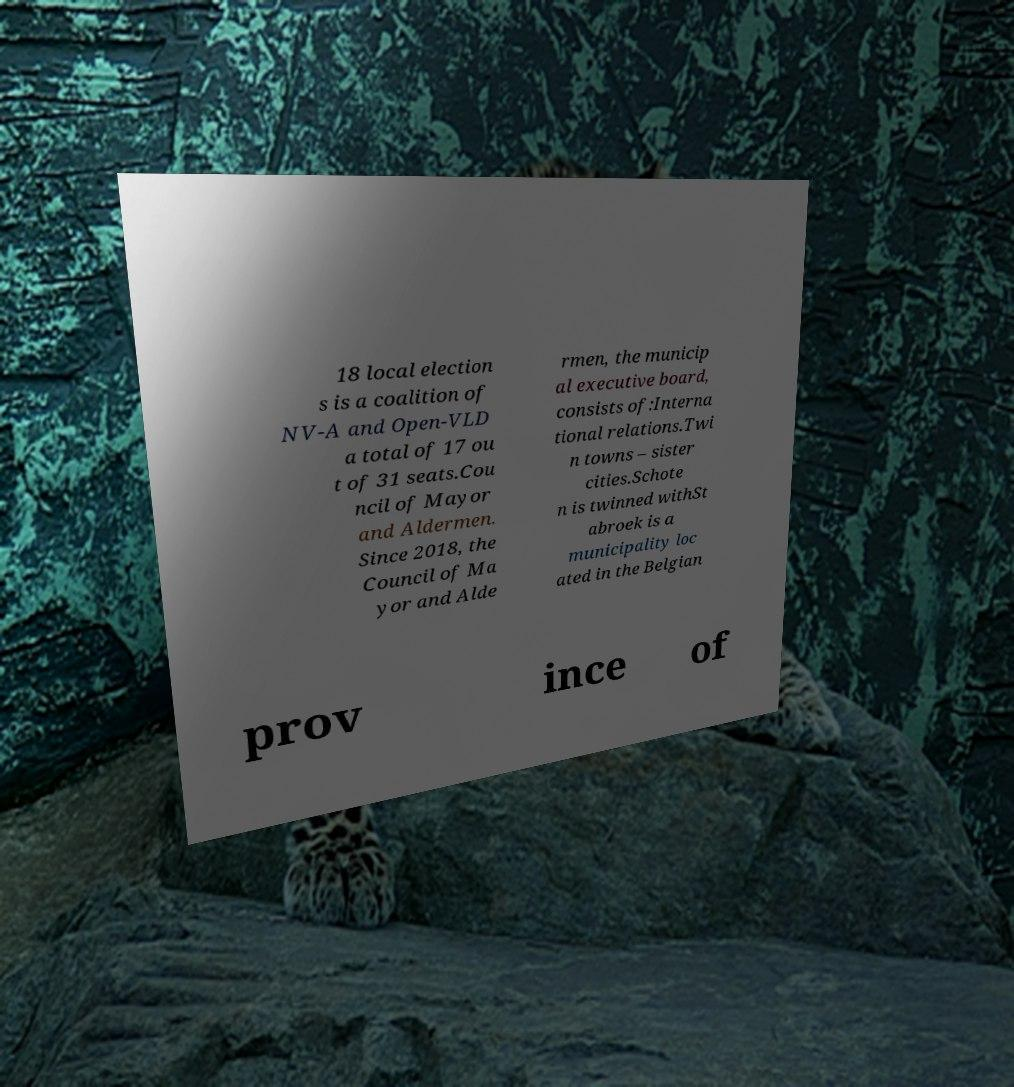I need the written content from this picture converted into text. Can you do that? 18 local election s is a coalition of NV-A and Open-VLD a total of 17 ou t of 31 seats.Cou ncil of Mayor and Aldermen. Since 2018, the Council of Ma yor and Alde rmen, the municip al executive board, consists of:Interna tional relations.Twi n towns – sister cities.Schote n is twinned withSt abroek is a municipality loc ated in the Belgian prov ince of 